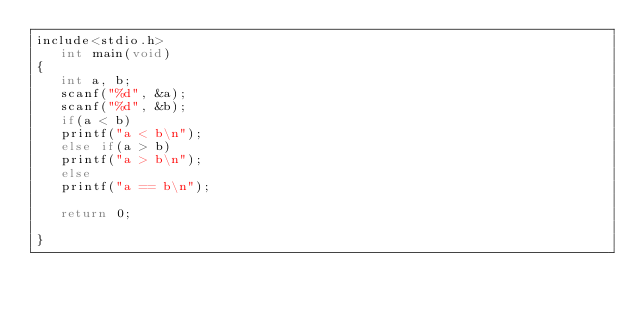<code> <loc_0><loc_0><loc_500><loc_500><_C_>include<stdio.h>
   int main(void)
{
   int a, b;
   scanf("%d", &a);
   scanf("%d", &b);
   if(a < b)
   printf("a < b\n");
   else if(a > b)
   printf("a > b\n");
   else
   printf("a == b\n");

   return 0;

}</code> 